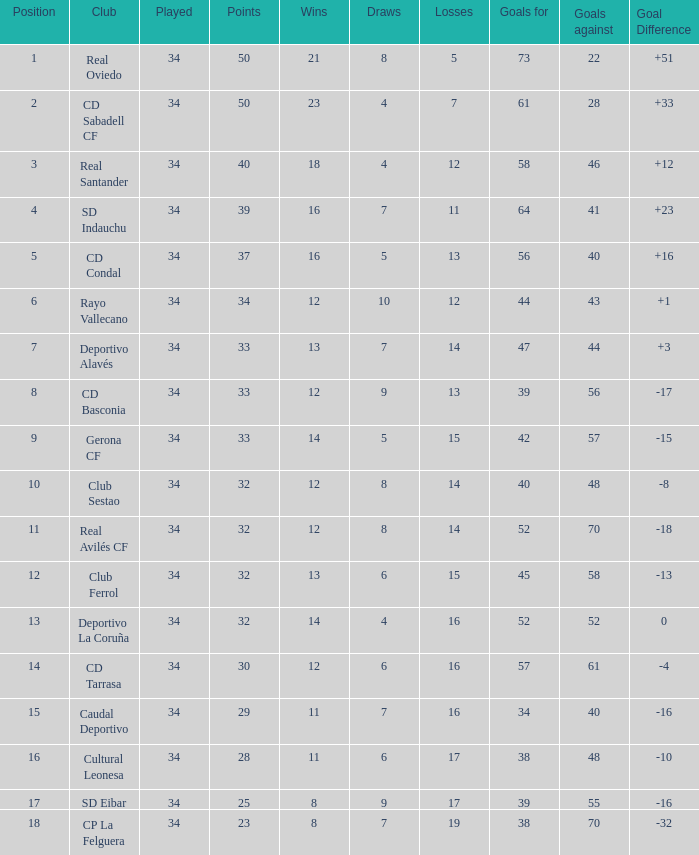Which Losses have a Goal Difference of -16, and less than 8 wins? None. 